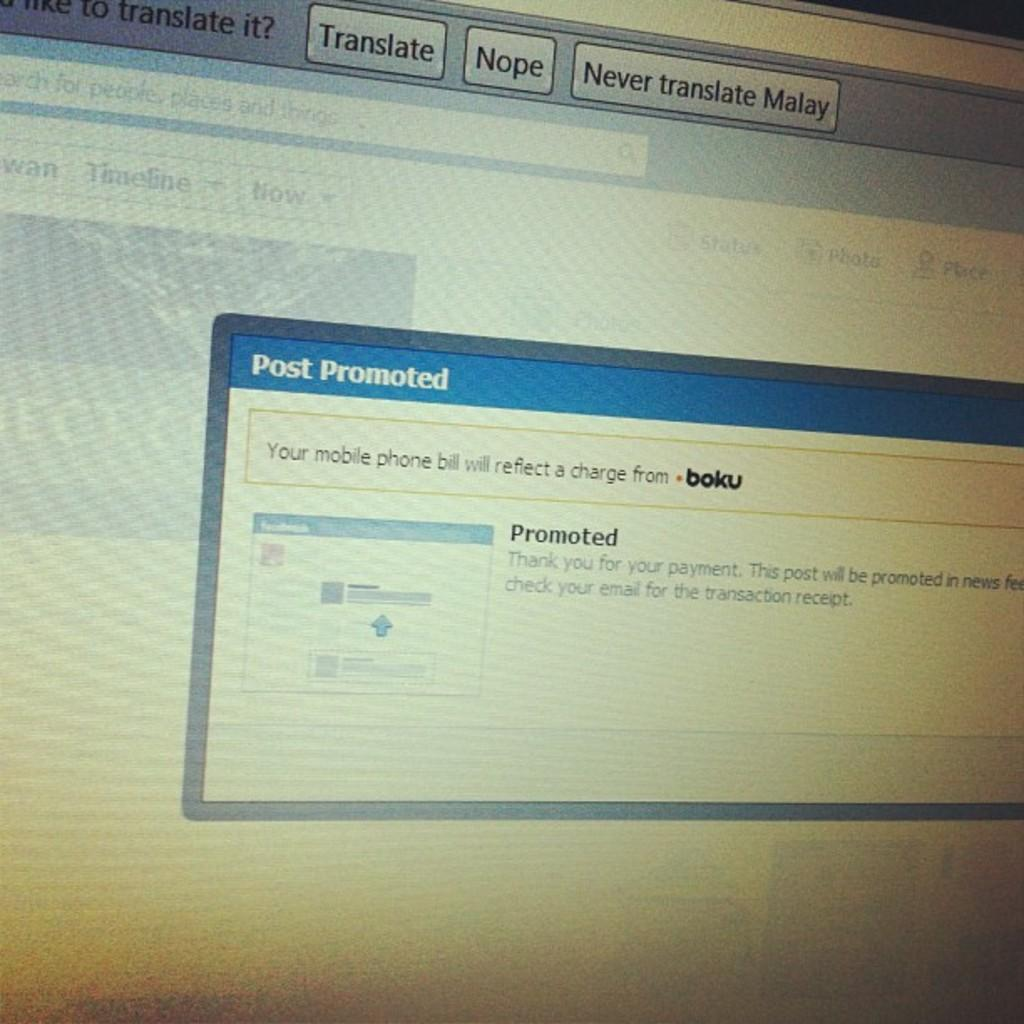Provide a one-sentence caption for the provided image. A pop up screen on a computer is titled Post Promoted. 